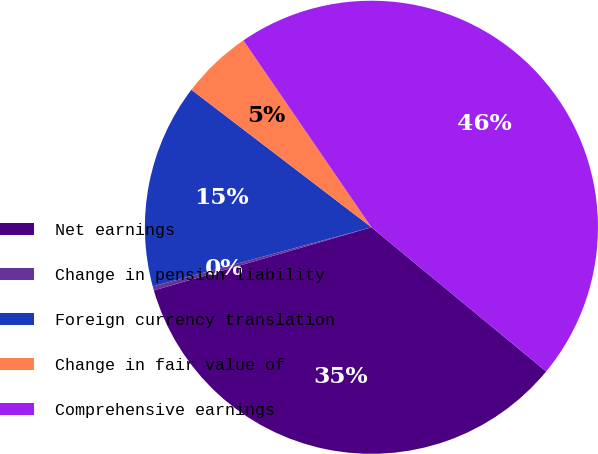Convert chart. <chart><loc_0><loc_0><loc_500><loc_500><pie_chart><fcel>Net earnings<fcel>Change in pension liability<fcel>Foreign currency translation<fcel>Change in fair value of<fcel>Comprehensive earnings<nl><fcel>34.53%<fcel>0.29%<fcel>14.59%<fcel>5.06%<fcel>45.54%<nl></chart> 